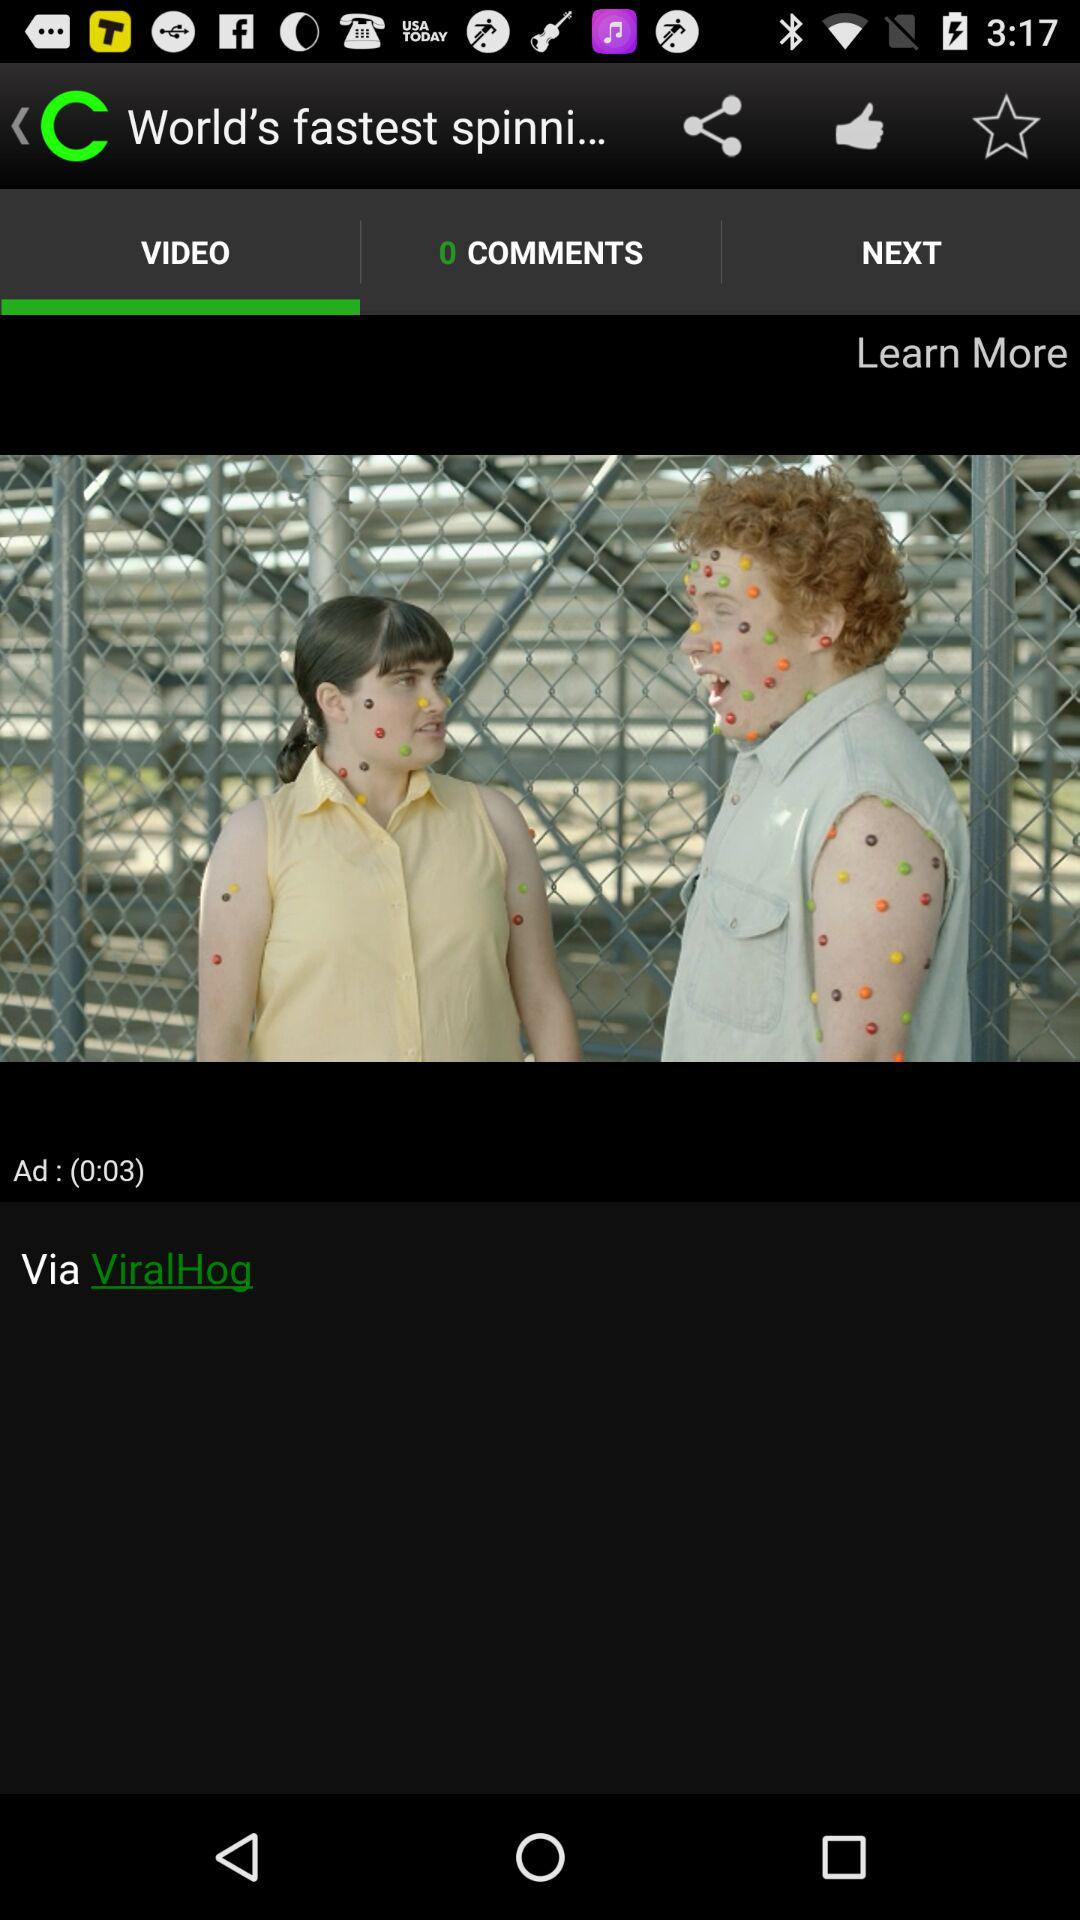Which tab is selected? The selected tab is "VIDEO". 